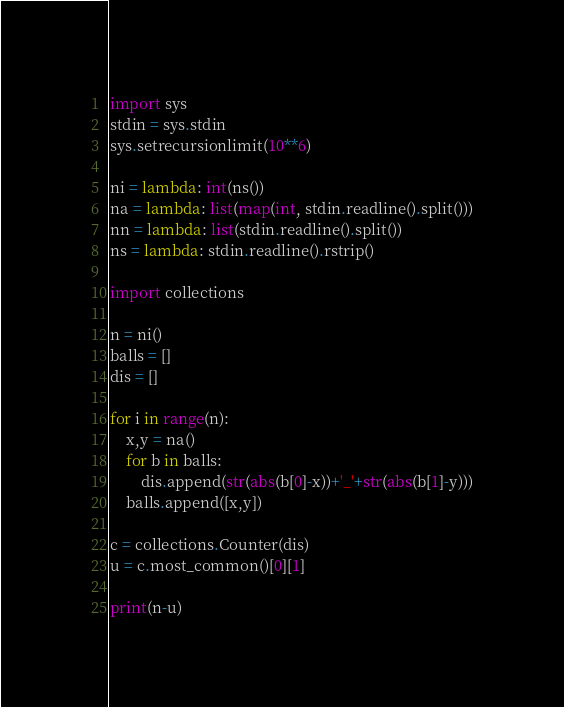<code> <loc_0><loc_0><loc_500><loc_500><_Python_>import sys
stdin = sys.stdin
sys.setrecursionlimit(10**6)
 
ni = lambda: int(ns())
na = lambda: list(map(int, stdin.readline().split()))
nn = lambda: list(stdin.readline().split())
ns = lambda: stdin.readline().rstrip()

import collections

n = ni()
balls = []
dis = []

for i in range(n):
    x,y = na()
    for b in balls:
        dis.append(str(abs(b[0]-x))+'_'+str(abs(b[1]-y)))
    balls.append([x,y])

c = collections.Counter(dis)
u = c.most_common()[0][1]

print(n-u)</code> 